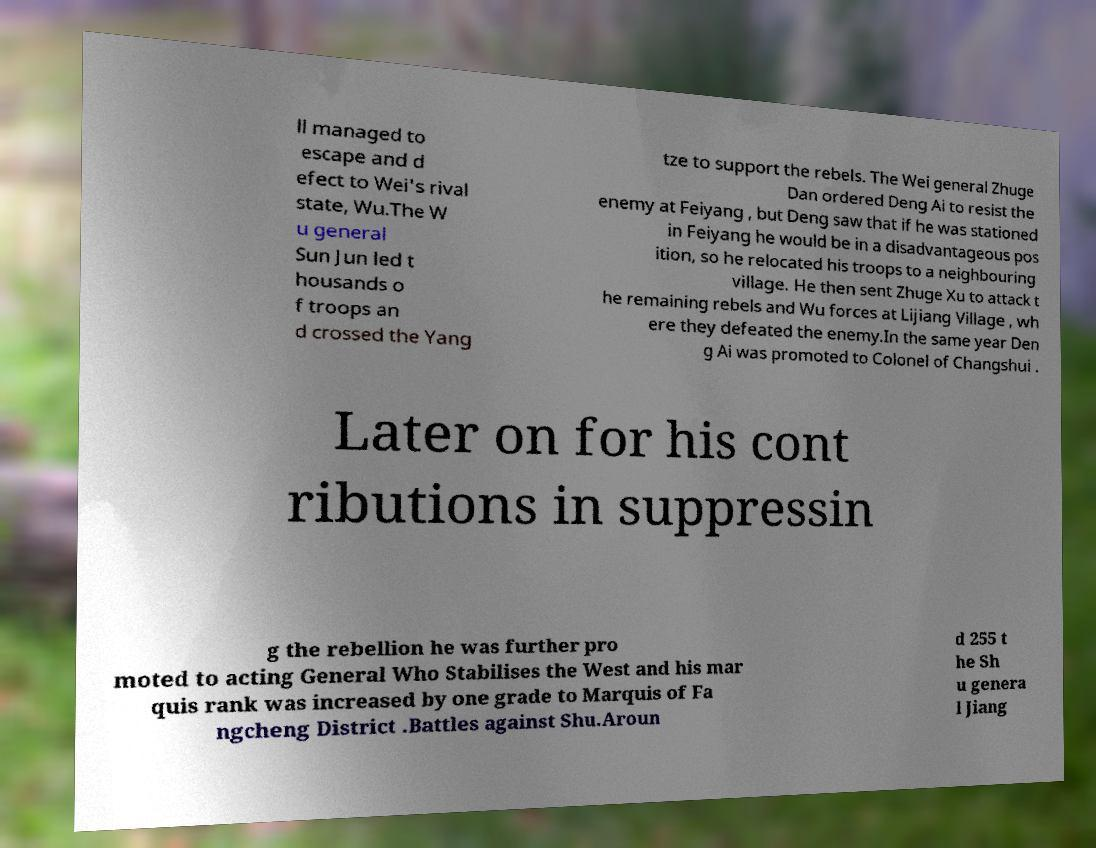Please read and relay the text visible in this image. What does it say? ll managed to escape and d efect to Wei's rival state, Wu.The W u general Sun Jun led t housands o f troops an d crossed the Yang tze to support the rebels. The Wei general Zhuge Dan ordered Deng Ai to resist the enemy at Feiyang , but Deng saw that if he was stationed in Feiyang he would be in a disadvantageous pos ition, so he relocated his troops to a neighbouring village. He then sent Zhuge Xu to attack t he remaining rebels and Wu forces at Lijiang Village , wh ere they defeated the enemy.In the same year Den g Ai was promoted to Colonel of Changshui . Later on for his cont ributions in suppressin g the rebellion he was further pro moted to acting General Who Stabilises the West and his mar quis rank was increased by one grade to Marquis of Fa ngcheng District .Battles against Shu.Aroun d 255 t he Sh u genera l Jiang 